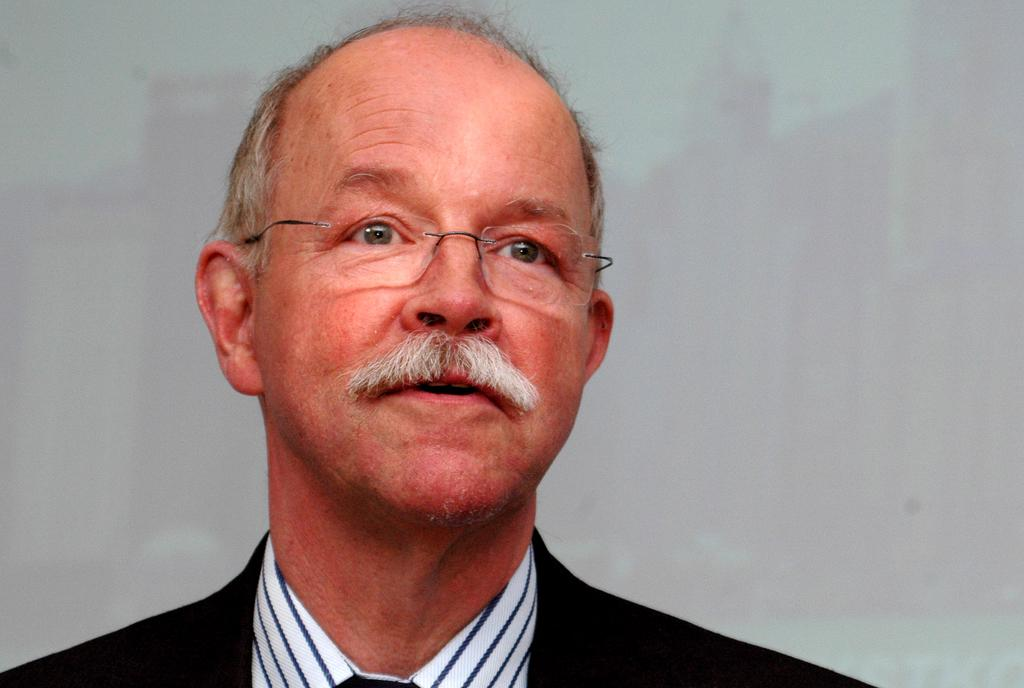Who is the main subject in the image? There is a man in the picture. What is the man wearing on his face? The man is wearing spectacles. What color is the background of the image? The background of the image is white. What color is the man's coat? The man is wearing a black coat. How many frogs are sitting on the man's leg in the image? There are no frogs present in the image, and the man's leg is not visible. On which side of the man is the white background located? The white background is behind the man, so it is not located on a specific side. 